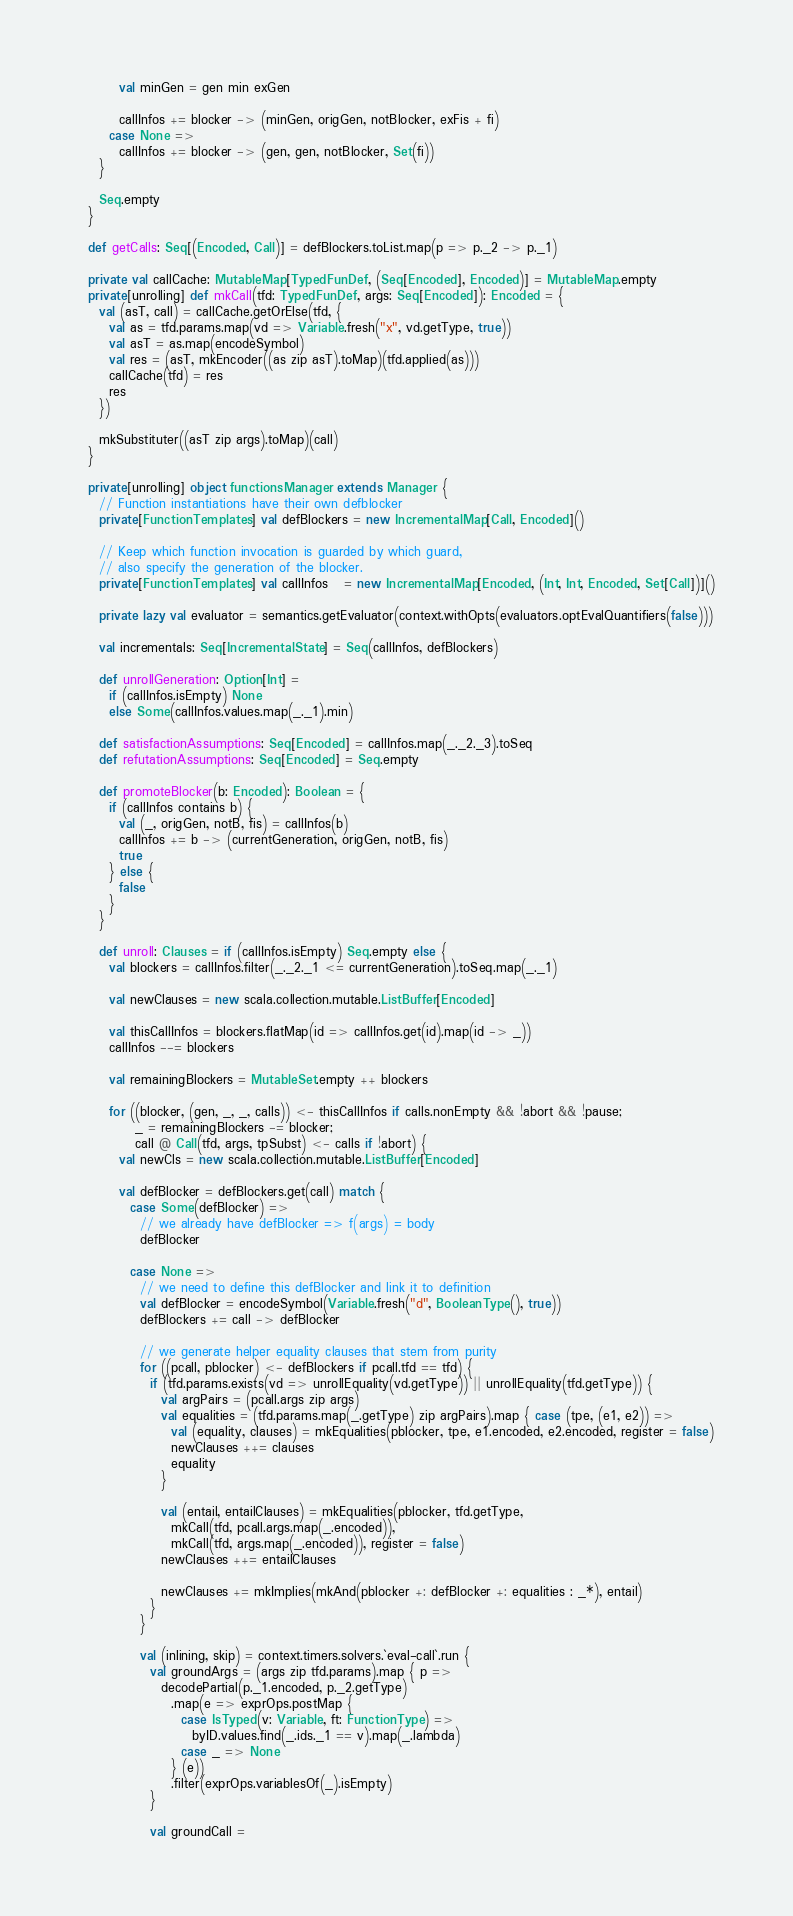<code> <loc_0><loc_0><loc_500><loc_500><_Scala_>        val minGen = gen min exGen

        callInfos += blocker -> (minGen, origGen, notBlocker, exFis + fi)
      case None =>
        callInfos += blocker -> (gen, gen, notBlocker, Set(fi))
    }

    Seq.empty
  }

  def getCalls: Seq[(Encoded, Call)] = defBlockers.toList.map(p => p._2 -> p._1)

  private val callCache: MutableMap[TypedFunDef, (Seq[Encoded], Encoded)] = MutableMap.empty
  private[unrolling] def mkCall(tfd: TypedFunDef, args: Seq[Encoded]): Encoded = {
    val (asT, call) = callCache.getOrElse(tfd, {
      val as = tfd.params.map(vd => Variable.fresh("x", vd.getType, true))
      val asT = as.map(encodeSymbol)
      val res = (asT, mkEncoder((as zip asT).toMap)(tfd.applied(as)))
      callCache(tfd) = res
      res
    })

    mkSubstituter((asT zip args).toMap)(call)
  }

  private[unrolling] object functionsManager extends Manager {
    // Function instantiations have their own defblocker
    private[FunctionTemplates] val defBlockers = new IncrementalMap[Call, Encoded]()

    // Keep which function invocation is guarded by which guard,
    // also specify the generation of the blocker.
    private[FunctionTemplates] val callInfos   = new IncrementalMap[Encoded, (Int, Int, Encoded, Set[Call])]()

    private lazy val evaluator = semantics.getEvaluator(context.withOpts(evaluators.optEvalQuantifiers(false)))

    val incrementals: Seq[IncrementalState] = Seq(callInfos, defBlockers)

    def unrollGeneration: Option[Int] =
      if (callInfos.isEmpty) None
      else Some(callInfos.values.map(_._1).min)

    def satisfactionAssumptions: Seq[Encoded] = callInfos.map(_._2._3).toSeq
    def refutationAssumptions: Seq[Encoded] = Seq.empty

    def promoteBlocker(b: Encoded): Boolean = {
      if (callInfos contains b) {
        val (_, origGen, notB, fis) = callInfos(b)
        callInfos += b -> (currentGeneration, origGen, notB, fis)
        true
      } else {
        false
      }
    }

    def unroll: Clauses = if (callInfos.isEmpty) Seq.empty else {
      val blockers = callInfos.filter(_._2._1 <= currentGeneration).toSeq.map(_._1)

      val newClauses = new scala.collection.mutable.ListBuffer[Encoded]

      val thisCallInfos = blockers.flatMap(id => callInfos.get(id).map(id -> _))
      callInfos --= blockers

      val remainingBlockers = MutableSet.empty ++ blockers

      for ((blocker, (gen, _, _, calls)) <- thisCallInfos if calls.nonEmpty && !abort && !pause;
           _ = remainingBlockers -= blocker;
           call @ Call(tfd, args, tpSubst) <- calls if !abort) {
        val newCls = new scala.collection.mutable.ListBuffer[Encoded]

        val defBlocker = defBlockers.get(call) match {
          case Some(defBlocker) =>
            // we already have defBlocker => f(args) = body
            defBlocker

          case None =>
            // we need to define this defBlocker and link it to definition
            val defBlocker = encodeSymbol(Variable.fresh("d", BooleanType(), true))
            defBlockers += call -> defBlocker

            // we generate helper equality clauses that stem from purity
            for ((pcall, pblocker) <- defBlockers if pcall.tfd == tfd) {
              if (tfd.params.exists(vd => unrollEquality(vd.getType)) || unrollEquality(tfd.getType)) {
                val argPairs = (pcall.args zip args)
                val equalities = (tfd.params.map(_.getType) zip argPairs).map { case (tpe, (e1, e2)) =>
                  val (equality, clauses) = mkEqualities(pblocker, tpe, e1.encoded, e2.encoded, register = false)
                  newClauses ++= clauses
                  equality
                }

                val (entail, entailClauses) = mkEqualities(pblocker, tfd.getType,
                  mkCall(tfd, pcall.args.map(_.encoded)),
                  mkCall(tfd, args.map(_.encoded)), register = false)
                newClauses ++= entailClauses

                newClauses += mkImplies(mkAnd(pblocker +: defBlocker +: equalities : _*), entail)
              }
            }

            val (inlining, skip) = context.timers.solvers.`eval-call`.run {
              val groundArgs = (args zip tfd.params).map { p =>
                decodePartial(p._1.encoded, p._2.getType)
                  .map(e => exprOps.postMap {
                    case IsTyped(v: Variable, ft: FunctionType) =>
                      byID.values.find(_.ids._1 == v).map(_.lambda)
                    case _ => None
                  } (e))
                  .filter(exprOps.variablesOf(_).isEmpty)
              }

              val groundCall =</code> 